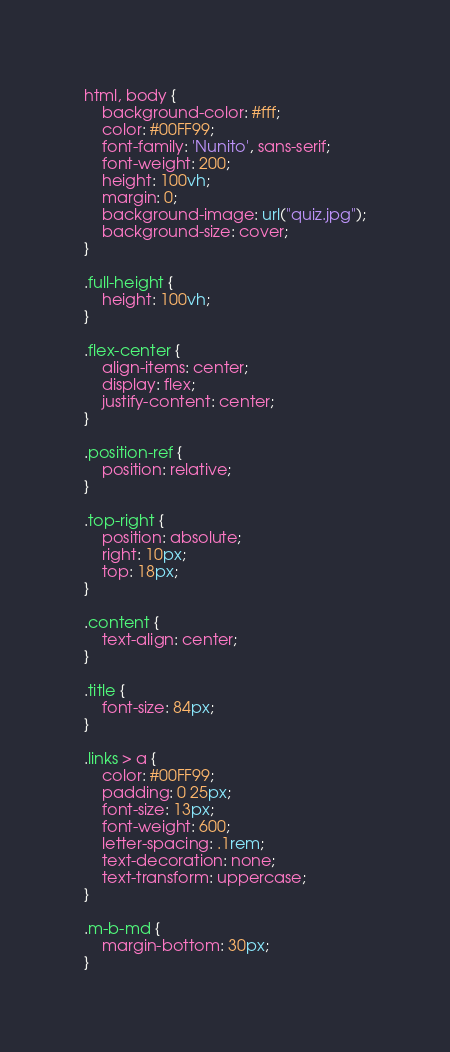<code> <loc_0><loc_0><loc_500><loc_500><_CSS_>html, body {
    background-color: #fff;
    color: #00FF99;
    font-family: 'Nunito', sans-serif;
    font-weight: 200;
    height: 100vh;
    margin: 0;
    background-image: url("quiz.jpg");
    background-size: cover;
}

.full-height {
    height: 100vh;
}

.flex-center {
    align-items: center;
    display: flex;
    justify-content: center;
}

.position-ref {
    position: relative;
}

.top-right {
    position: absolute;
    right: 10px;
    top: 18px;
}

.content {
    text-align: center;
}

.title {
    font-size: 84px;
}

.links > a {
    color: #00FF99;
    padding: 0 25px;
    font-size: 13px;
    font-weight: 600;
    letter-spacing: .1rem;
    text-decoration: none;
    text-transform: uppercase;
}

.m-b-md {
    margin-bottom: 30px;
}</code> 